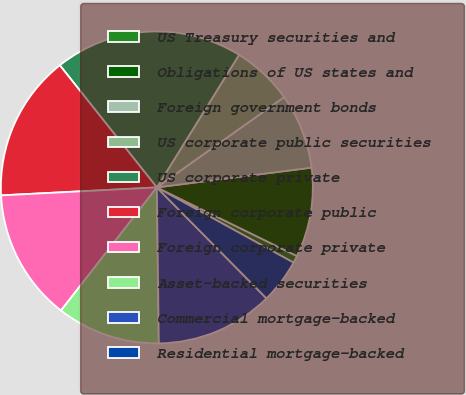<chart> <loc_0><loc_0><loc_500><loc_500><pie_chart><fcel>US Treasury securities and<fcel>Obligations of US states and<fcel>Foreign government bonds<fcel>US corporate public securities<fcel>US corporate private<fcel>Foreign corporate public<fcel>Foreign corporate private<fcel>Asset-backed securities<fcel>Commercial mortgage-backed<fcel>Residential mortgage-backed<nl><fcel>0.76%<fcel>9.27%<fcel>7.8%<fcel>6.34%<fcel>19.52%<fcel>15.13%<fcel>13.66%<fcel>10.73%<fcel>12.2%<fcel>4.59%<nl></chart> 